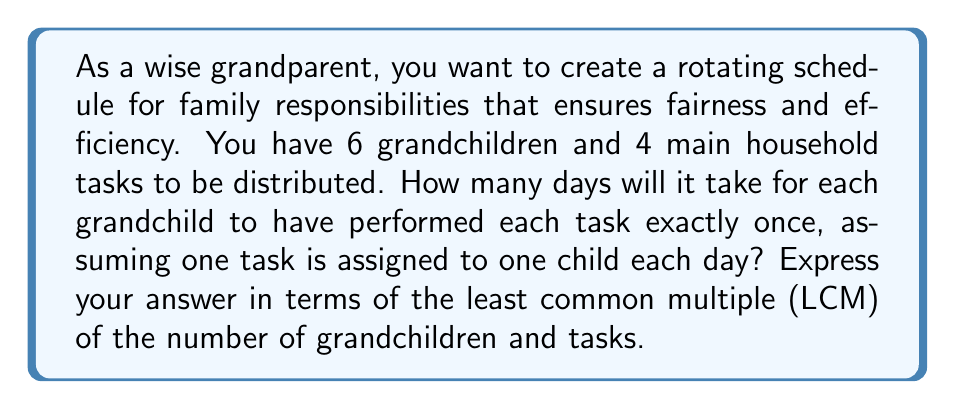Teach me how to tackle this problem. To solve this problem, we need to understand the concept of the least common multiple (LCM) and how it applies to creating an efficient rotating schedule.

1) First, let's identify our key numbers:
   - Number of grandchildren: 6
   - Number of tasks: 4

2) For a complete rotation where each grandchild has performed each task once:
   - Each grandchild needs to perform 4 tasks
   - Each task needs to be performed by 6 grandchildren

3) The total number of task assignments needed is:
   $6 \times 4 = 24$

4) Now, we need to find how many days this will take. This is where the LCM comes in.

5) The LCM of 6 and 4 is the smallest number that is divisible by both 6 and 4.
   To find the LCM, let's first find the prime factorization of 6 and 4:
   $6 = 2 \times 3$
   $4 = 2^2$

6) The LCM will include the highest power of each prime factor:
   $LCM(6,4) = 2^2 \times 3 = 12$

7) This means that every 12 days, the schedule will complete one full cycle where:
   - Each of the 6 grandchildren has been assigned 2 tasks
   - Each of the 4 tasks has been assigned 3 times

8) To complete the full rotation where each grandchild has done each task once, we need:
   $\frac{24}{12} = 2$ cycles

9) Therefore, the total number of days needed is:
   $2 \times LCM(6,4) = 2 \times 12 = 24$

This schedule ensures that every 24 days, each grandchild will have performed each task exactly once, creating a fair and efficient rotation.
Answer: $2 \times LCM(6,4) = 24$ days 